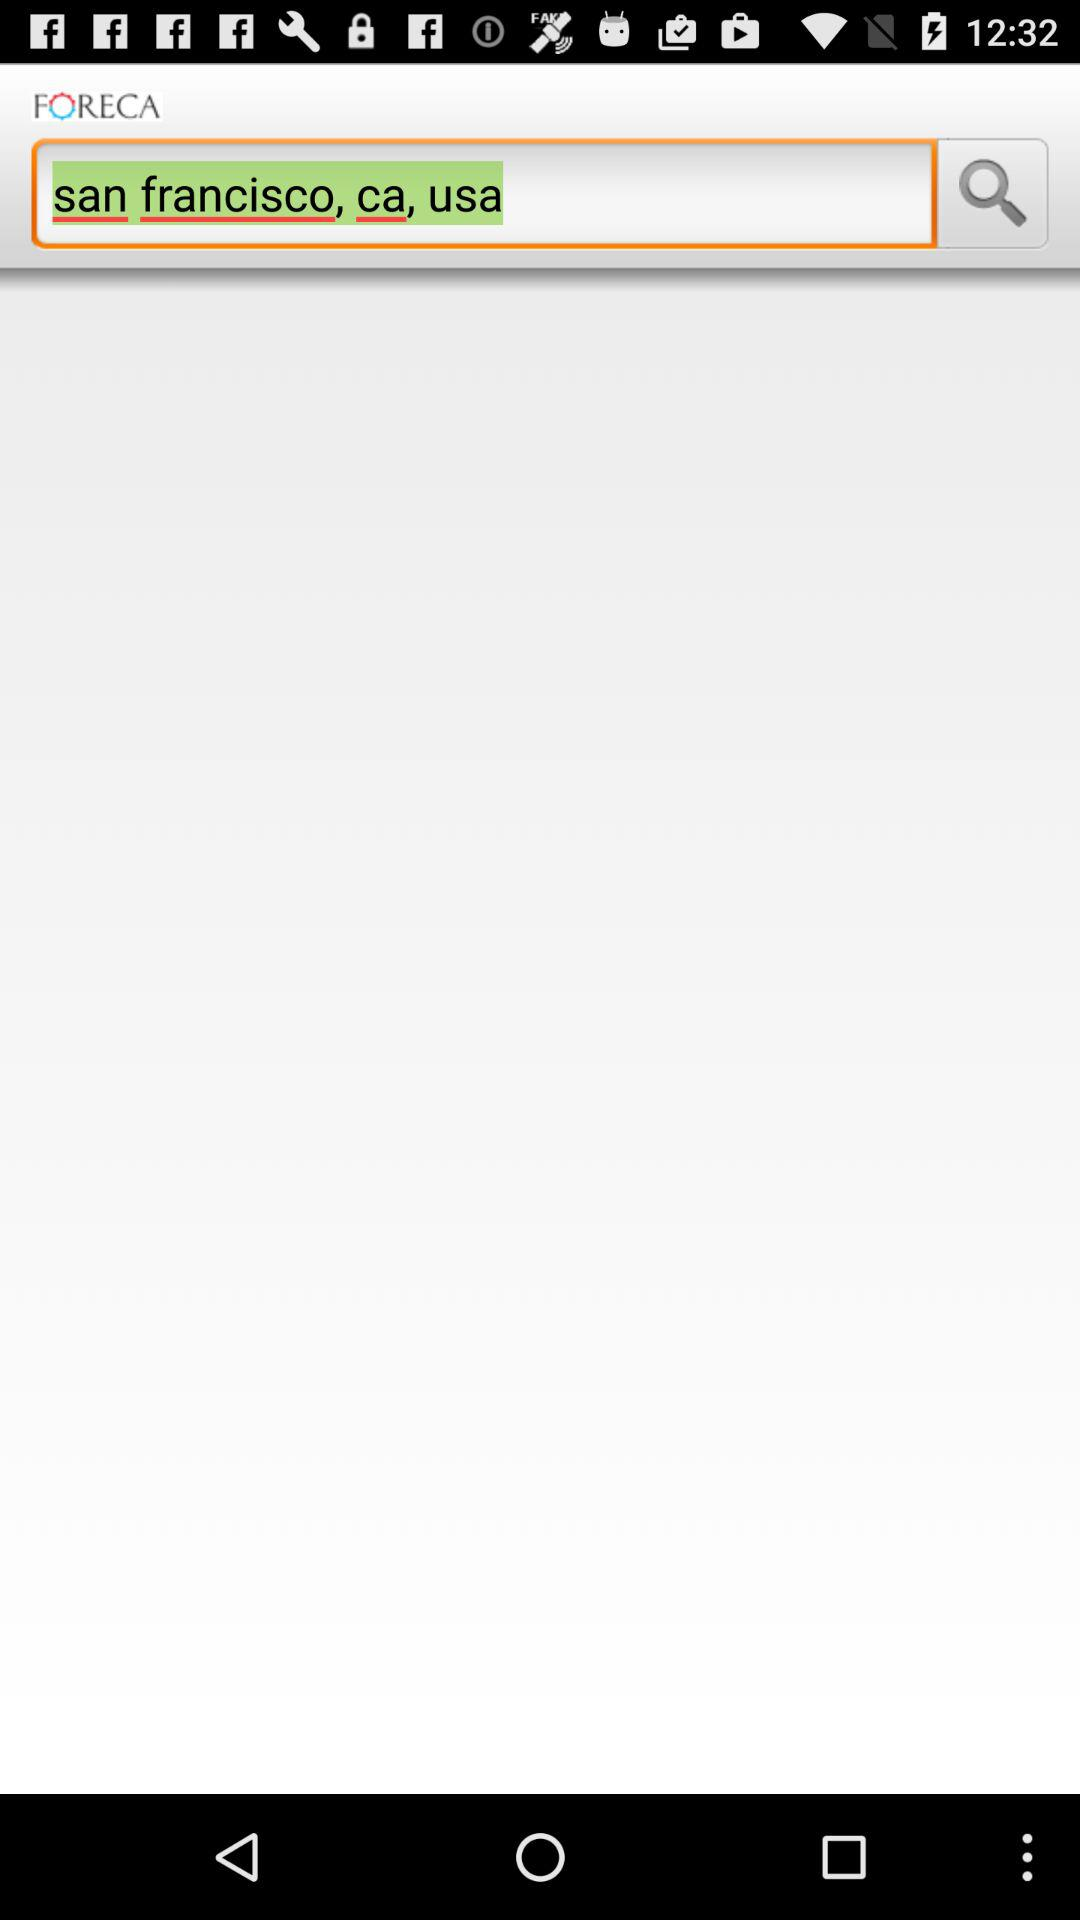What is the location in the search box? The location in the search box is San Francisco, Ca, USA. 